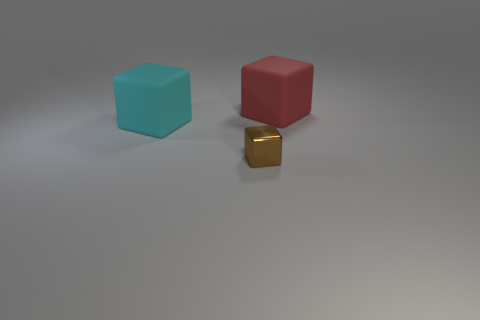Subtract all big cyan cubes. How many cubes are left? 2 Add 1 brown metallic blocks. How many objects exist? 4 Subtract all cyan cubes. How many cubes are left? 2 Subtract all tiny purple rubber things. Subtract all cyan blocks. How many objects are left? 2 Add 2 small cubes. How many small cubes are left? 3 Add 3 matte objects. How many matte objects exist? 5 Subtract 0 blue blocks. How many objects are left? 3 Subtract 2 blocks. How many blocks are left? 1 Subtract all brown blocks. Subtract all red spheres. How many blocks are left? 2 